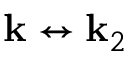Convert formula to latex. <formula><loc_0><loc_0><loc_500><loc_500>{ k } \leftrightarrow { k } _ { 2 }</formula> 